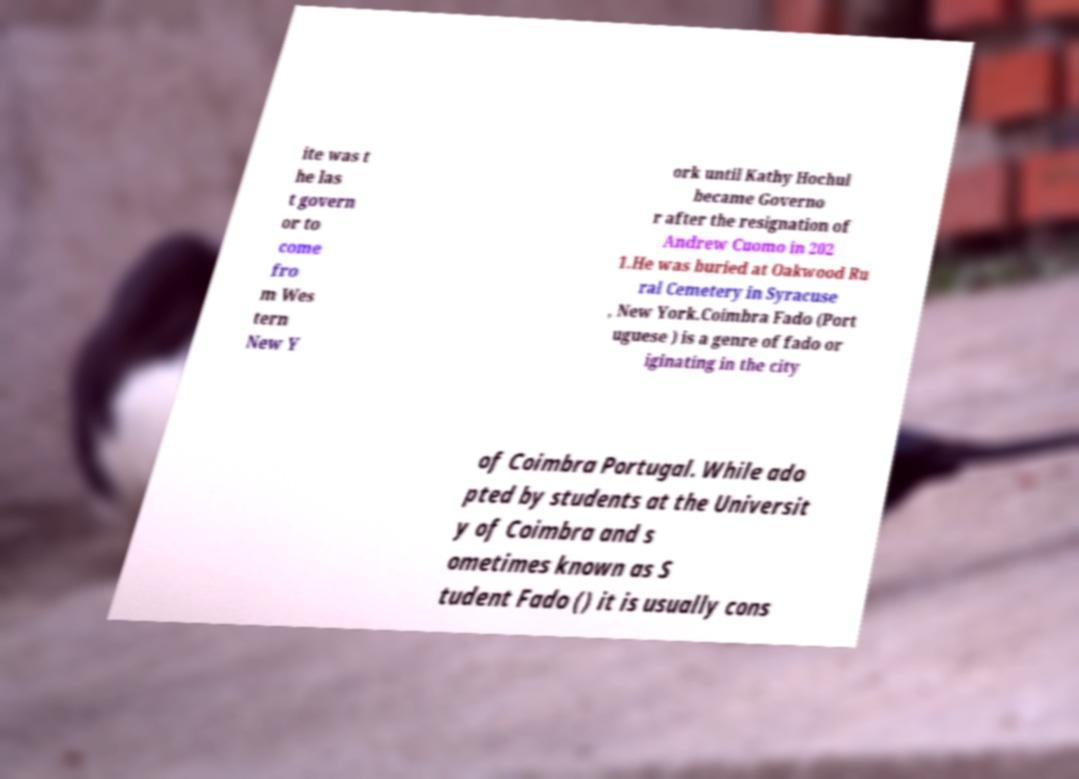I need the written content from this picture converted into text. Can you do that? ite was t he las t govern or to come fro m Wes tern New Y ork until Kathy Hochul became Governo r after the resignation of Andrew Cuomo in 202 1.He was buried at Oakwood Ru ral Cemetery in Syracuse , New York.Coimbra Fado (Port uguese ) is a genre of fado or iginating in the city of Coimbra Portugal. While ado pted by students at the Universit y of Coimbra and s ometimes known as S tudent Fado () it is usually cons 